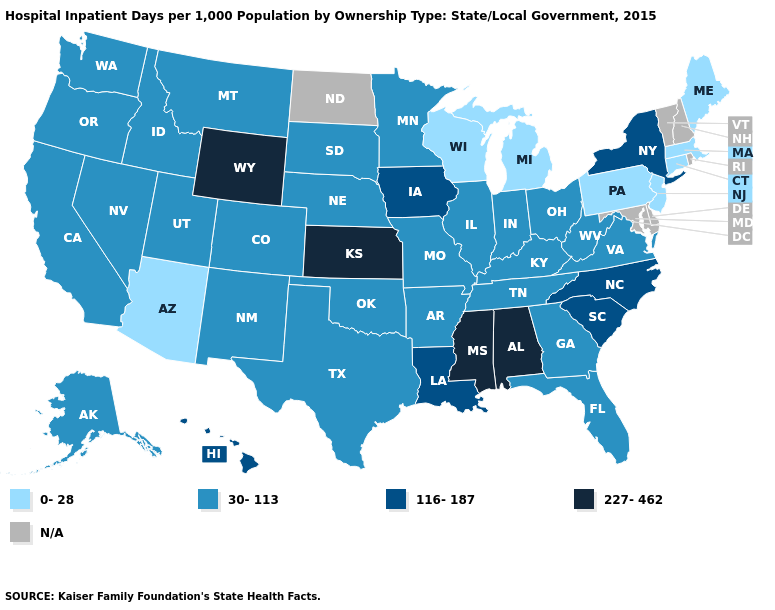Name the states that have a value in the range 30-113?
Write a very short answer. Alaska, Arkansas, California, Colorado, Florida, Georgia, Idaho, Illinois, Indiana, Kentucky, Minnesota, Missouri, Montana, Nebraska, Nevada, New Mexico, Ohio, Oklahoma, Oregon, South Dakota, Tennessee, Texas, Utah, Virginia, Washington, West Virginia. Which states have the lowest value in the Northeast?
Keep it brief. Connecticut, Maine, Massachusetts, New Jersey, Pennsylvania. Does Wisconsin have the lowest value in the MidWest?
Concise answer only. Yes. Which states have the highest value in the USA?
Give a very brief answer. Alabama, Kansas, Mississippi, Wyoming. What is the value of Tennessee?
Short answer required. 30-113. What is the highest value in the Northeast ?
Answer briefly. 116-187. Name the states that have a value in the range 116-187?
Write a very short answer. Hawaii, Iowa, Louisiana, New York, North Carolina, South Carolina. What is the value of Delaware?
Give a very brief answer. N/A. What is the lowest value in states that border Idaho?
Short answer required. 30-113. What is the value of Kentucky?
Answer briefly. 30-113. Name the states that have a value in the range 0-28?
Answer briefly. Arizona, Connecticut, Maine, Massachusetts, Michigan, New Jersey, Pennsylvania, Wisconsin. What is the highest value in the South ?
Short answer required. 227-462. Name the states that have a value in the range 0-28?
Concise answer only. Arizona, Connecticut, Maine, Massachusetts, Michigan, New Jersey, Pennsylvania, Wisconsin. Which states have the highest value in the USA?
Concise answer only. Alabama, Kansas, Mississippi, Wyoming. What is the value of Louisiana?
Be succinct. 116-187. 